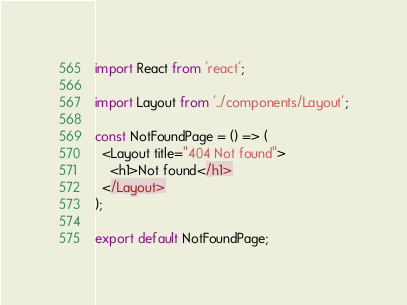<code> <loc_0><loc_0><loc_500><loc_500><_JavaScript_>import React from 'react';

import Layout from '../components/Layout';

const NotFoundPage = () => (
  <Layout title="404 Not found">
    <h1>Not found</h1>
  </Layout>
);

export default NotFoundPage;
</code> 